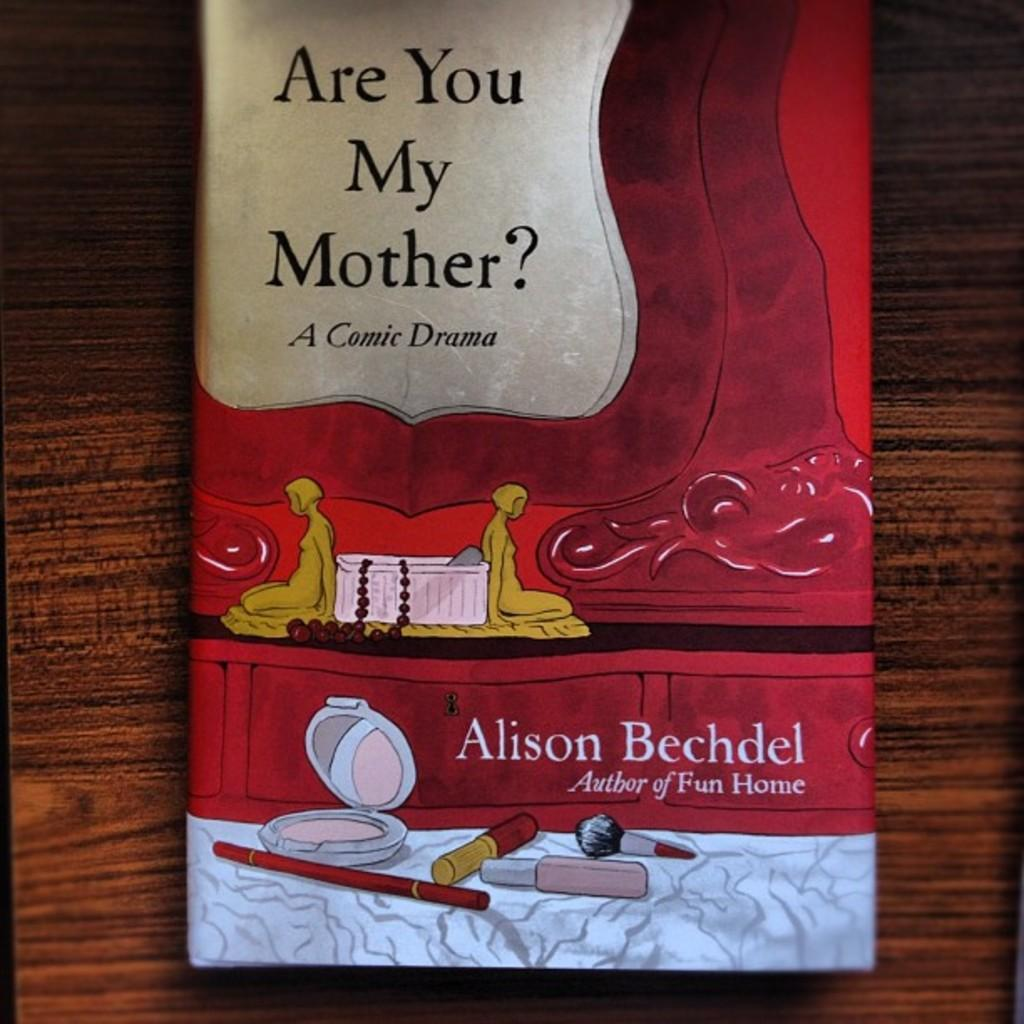<image>
Share a concise interpretation of the image provided. A book Called Are you My Mother sit on a wood table. 